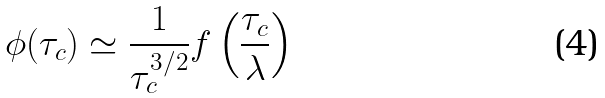<formula> <loc_0><loc_0><loc_500><loc_500>\phi ( \tau _ { c } ) \simeq \frac { 1 } { \tau _ { c } ^ { 3 / 2 } } f \left ( \frac { \tau _ { c } } { \lambda } \right )</formula> 